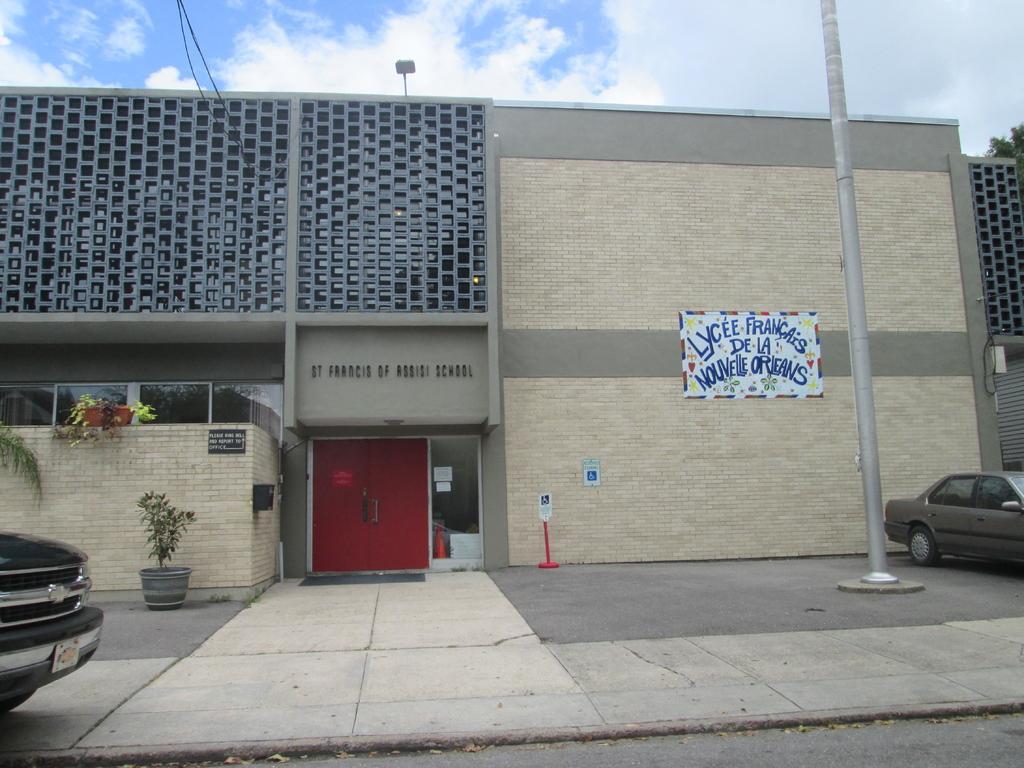Describe this image in one or two sentences. In this picture I can see vehicles, there are plants, boards, there is a building, and in the background there is the sky. 